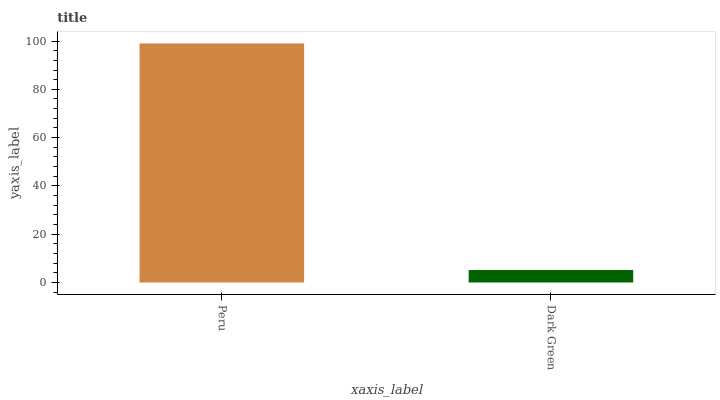Is Dark Green the maximum?
Answer yes or no. No. Is Peru greater than Dark Green?
Answer yes or no. Yes. Is Dark Green less than Peru?
Answer yes or no. Yes. Is Dark Green greater than Peru?
Answer yes or no. No. Is Peru less than Dark Green?
Answer yes or no. No. Is Peru the high median?
Answer yes or no. Yes. Is Dark Green the low median?
Answer yes or no. Yes. Is Dark Green the high median?
Answer yes or no. No. Is Peru the low median?
Answer yes or no. No. 